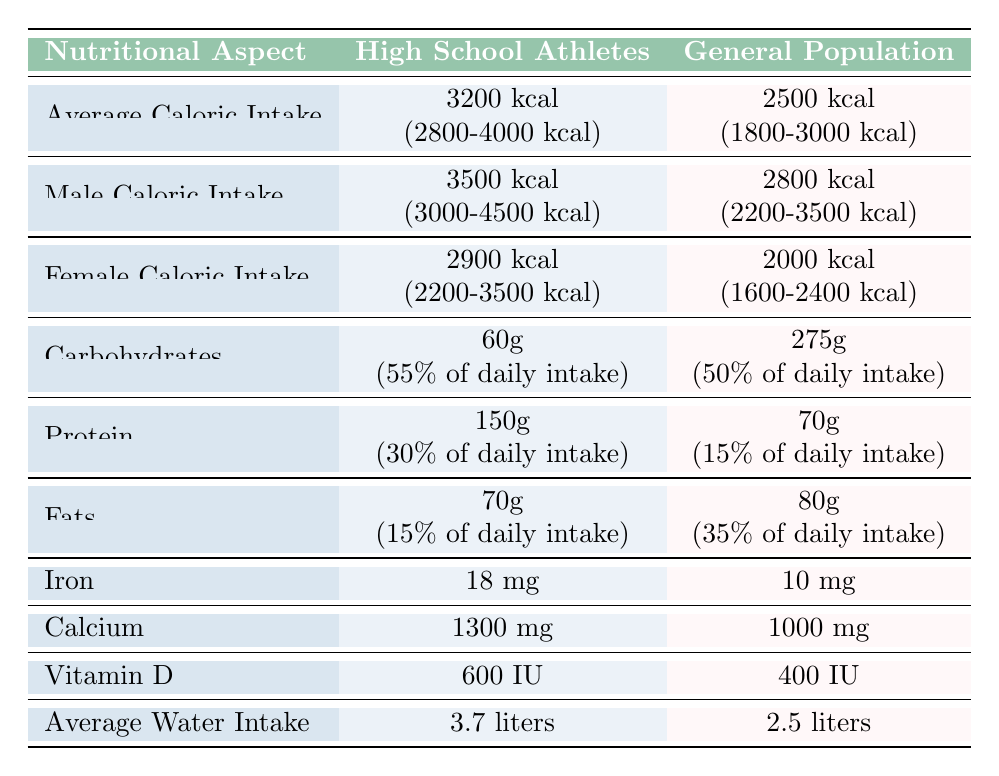What is the average caloric intake for high school athletes? The table lists the average caloric intake for high school athletes as 3200 kcal. This is found in the "Average Caloric Intake" row under "High School Athletes".
Answer: 3200 kcal How much protein do high school athletes consume on average? The average protein intake for high school athletes is 150 grams, which is specified in the "Protein" row under "High School Athletes".
Answer: 150 grams Does the average female caloric intake for high school athletes exceed that of the general population? The average female caloric intake for high school athletes is 2900 kcal, and for the general population, it is 2000 kcal. Since 2900 is greater than 2000, the statement is true.
Answer: Yes What is the difference in average water intake between high school athletes and the general population? The average water intake for high school athletes is 3.7 liters, while for the general population, it is 2.5 liters. The difference is 3.7 - 2.5 = 1.2 liters.
Answer: 1.2 liters Is the average calcium intake higher for high school athletes compared to the general population? High school athletes have an average calcium intake of 1300 mg, whereas the general population averages 1000 mg. Since 1300 is greater than 1000, the statement is true.
Answer: Yes How much do high school athletes consume in fats compared to the average for the general population? High school athletes consume an average of 70 grams of fats, while the general population consumes 80 grams. Since 70 grams is less than 80 grams, high school athletes consume less.
Answer: Less What percentage of daily intake does carbohydrates represent for high school athletes? The table states that carbohydrates account for 55% of the daily intake for high school athletes, which is found in the "Carbohydrates" row.
Answer: 55% If you sum the average grams of macronutrients for high school athletes, what is the total? The average grams for each macronutrient are: Carbohydrates (60g), Protein (150g), and Fats (70g). The total is 60 + 150 + 70 = 280 grams.
Answer: 280 grams What is the average iron intake for high school athletes compared to the general population? High school athletes have an average iron intake of 18 mg and the general population has 10 mg. Since 18 mg is greater than 10 mg, high school athletes consume more iron.
Answer: More 